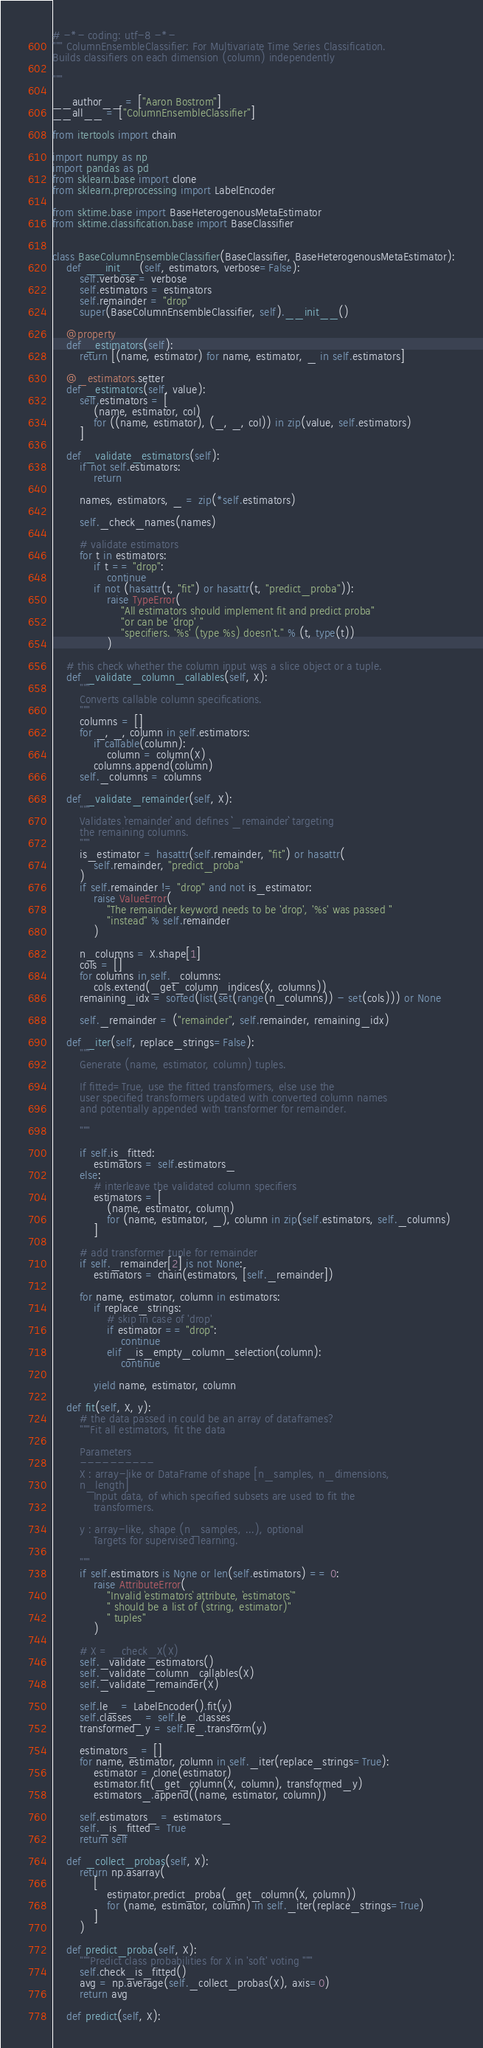Convert code to text. <code><loc_0><loc_0><loc_500><loc_500><_Python_># -*- coding: utf-8 -*-
""" ColumnEnsembleClassifier: For Multivariate Time Series Classification.
Builds classifiers on each dimension (column) independently

"""

__author__ = ["Aaron Bostrom"]
__all__ = ["ColumnEnsembleClassifier"]

from itertools import chain

import numpy as np
import pandas as pd
from sklearn.base import clone
from sklearn.preprocessing import LabelEncoder

from sktime.base import BaseHeterogenousMetaEstimator
from sktime.classification.base import BaseClassifier


class BaseColumnEnsembleClassifier(BaseClassifier, BaseHeterogenousMetaEstimator):
    def __init__(self, estimators, verbose=False):
        self.verbose = verbose
        self.estimators = estimators
        self.remainder = "drop"
        super(BaseColumnEnsembleClassifier, self).__init__()

    @property
    def _estimators(self):
        return [(name, estimator) for name, estimator, _ in self.estimators]

    @_estimators.setter
    def _estimators(self, value):
        self.estimators = [
            (name, estimator, col)
            for ((name, estimator), (_, _, col)) in zip(value, self.estimators)
        ]

    def _validate_estimators(self):
        if not self.estimators:
            return

        names, estimators, _ = zip(*self.estimators)

        self._check_names(names)

        # validate estimators
        for t in estimators:
            if t == "drop":
                continue
            if not (hasattr(t, "fit") or hasattr(t, "predict_proba")):
                raise TypeError(
                    "All estimators should implement fit and predict proba"
                    "or can be 'drop' "
                    "specifiers. '%s' (type %s) doesn't." % (t, type(t))
                )

    # this check whether the column input was a slice object or a tuple.
    def _validate_column_callables(self, X):
        """
        Converts callable column specifications.
        """
        columns = []
        for _, _, column in self.estimators:
            if callable(column):
                column = column(X)
            columns.append(column)
        self._columns = columns

    def _validate_remainder(self, X):
        """
        Validates ``remainder`` and defines ``_remainder`` targeting
        the remaining columns.
        """
        is_estimator = hasattr(self.remainder, "fit") or hasattr(
            self.remainder, "predict_proba"
        )
        if self.remainder != "drop" and not is_estimator:
            raise ValueError(
                "The remainder keyword needs to be 'drop', '%s' was passed "
                "instead" % self.remainder
            )

        n_columns = X.shape[1]
        cols = []
        for columns in self._columns:
            cols.extend(_get_column_indices(X, columns))
        remaining_idx = sorted(list(set(range(n_columns)) - set(cols))) or None

        self._remainder = ("remainder", self.remainder, remaining_idx)

    def _iter(self, replace_strings=False):
        """
        Generate (name, estimator, column) tuples.

        If fitted=True, use the fitted transformers, else use the
        user specified transformers updated with converted column names
        and potentially appended with transformer for remainder.

        """

        if self.is_fitted:
            estimators = self.estimators_
        else:
            # interleave the validated column specifiers
            estimators = [
                (name, estimator, column)
                for (name, estimator, _), column in zip(self.estimators, self._columns)
            ]

        # add transformer tuple for remainder
        if self._remainder[2] is not None:
            estimators = chain(estimators, [self._remainder])

        for name, estimator, column in estimators:
            if replace_strings:
                # skip in case of 'drop'
                if estimator == "drop":
                    continue
                elif _is_empty_column_selection(column):
                    continue

            yield name, estimator, column

    def fit(self, X, y):
        # the data passed in could be an array of dataframes?
        """Fit all estimators, fit the data

        Parameters
        ----------
        X : array-like or DataFrame of shape [n_samples, n_dimensions,
        n_length]
            Input data, of which specified subsets are used to fit the
            transformers.

        y : array-like, shape (n_samples, ...), optional
            Targets for supervised learning.

        """
        if self.estimators is None or len(self.estimators) == 0:
            raise AttributeError(
                "Invalid `estimators` attribute, `estimators`"
                " should be a list of (string, estimator)"
                " tuples"
            )

        # X = _check_X(X)
        self._validate_estimators()
        self._validate_column_callables(X)
        self._validate_remainder(X)

        self.le_ = LabelEncoder().fit(y)
        self.classes_ = self.le_.classes_
        transformed_y = self.le_.transform(y)

        estimators_ = []
        for name, estimator, column in self._iter(replace_strings=True):
            estimator = clone(estimator)
            estimator.fit(_get_column(X, column), transformed_y)
            estimators_.append((name, estimator, column))

        self.estimators_ = estimators_
        self._is_fitted = True
        return self

    def _collect_probas(self, X):
        return np.asarray(
            [
                estimator.predict_proba(_get_column(X, column))
                for (name, estimator, column) in self._iter(replace_strings=True)
            ]
        )

    def predict_proba(self, X):
        """Predict class probabilities for X in 'soft' voting """
        self.check_is_fitted()
        avg = np.average(self._collect_probas(X), axis=0)
        return avg

    def predict(self, X):</code> 